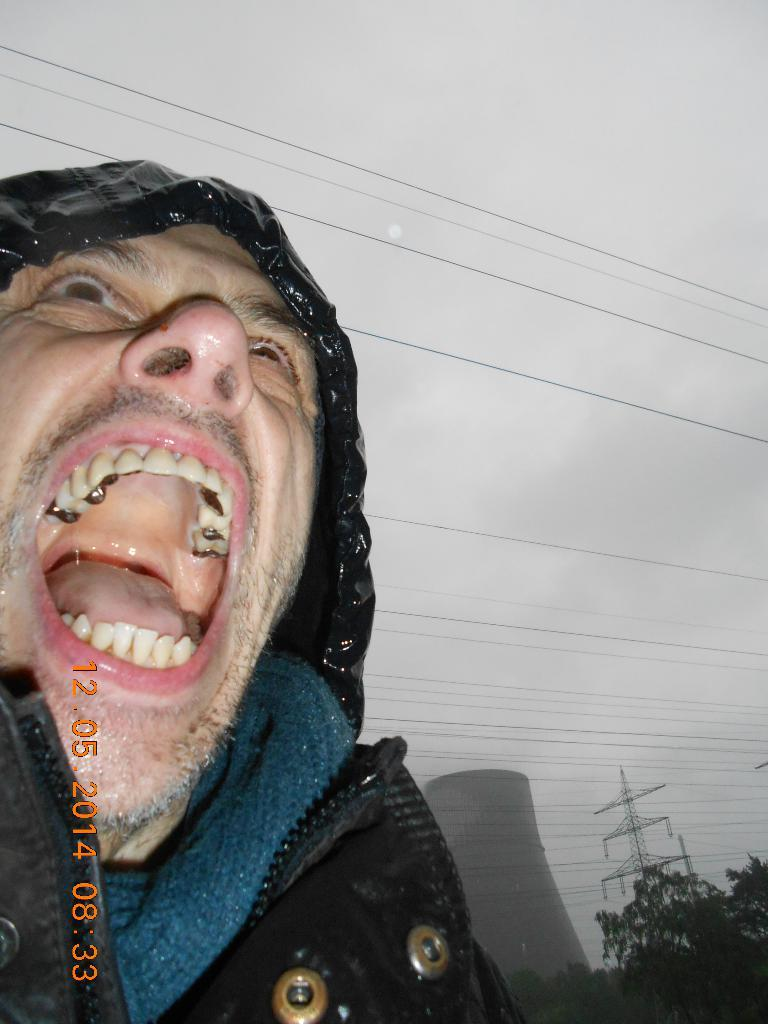Who is on the left side of the image? There is a man on the left side of the image. What can be seen in the bottom right corner of the image? There are trees and towers in the bottom right corner of the image. What is visible in the background of the image? The sky is visible in the background of the image. Where are the children playing in the image? There are no children present in the image. 